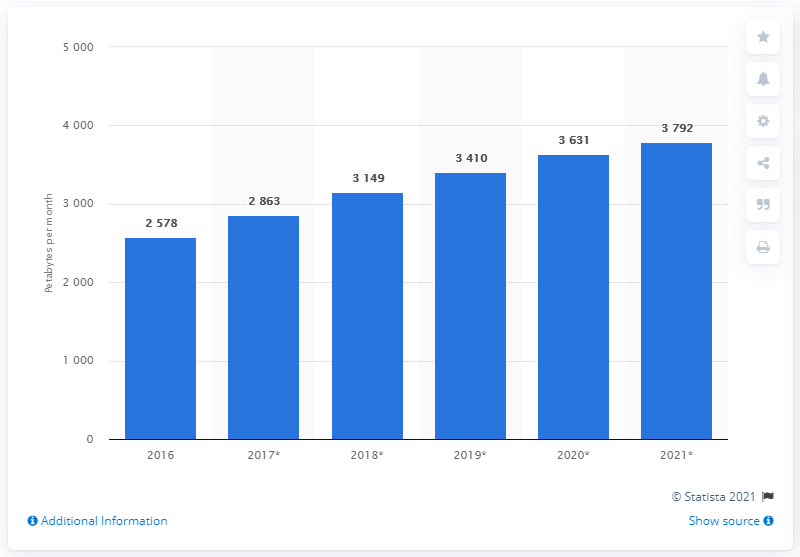Specify some key components in this picture. The median usage across all years is 3279.5. The unit used to measure the bars is petabytes per month. 